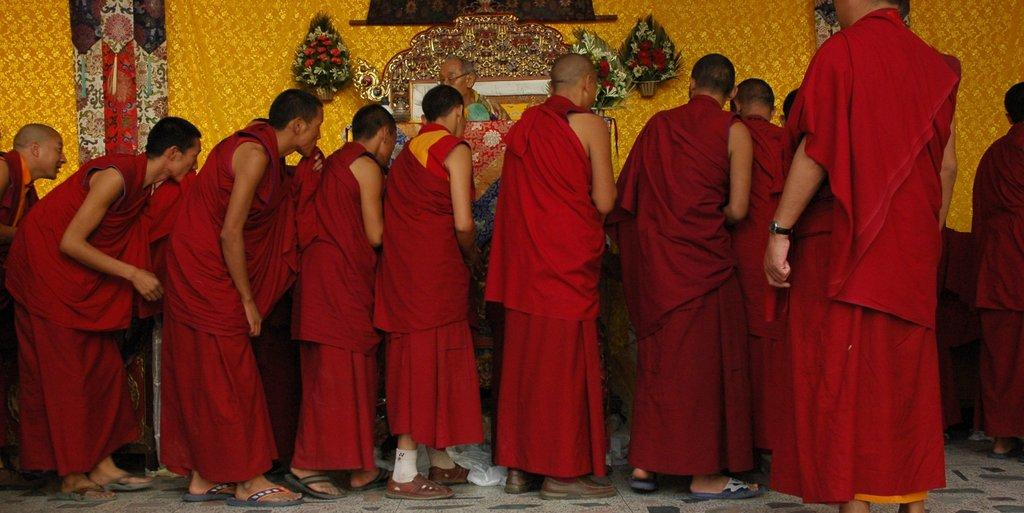What type of structure can be seen in the image? There is a wall in the image. What kind of vegetation is present in the image? There are flowers in the image. What piece of furniture is visible in the image? There is a table in the image. How many people are in the image, and what are they wearing? There is a group of people in the image, and they are wearing red color dresses. Can you tell me how many legs the flowers have in the image? Flowers do not have legs, so this question cannot be answered based on the information provided. 